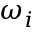Convert formula to latex. <formula><loc_0><loc_0><loc_500><loc_500>\omega _ { i }</formula> 